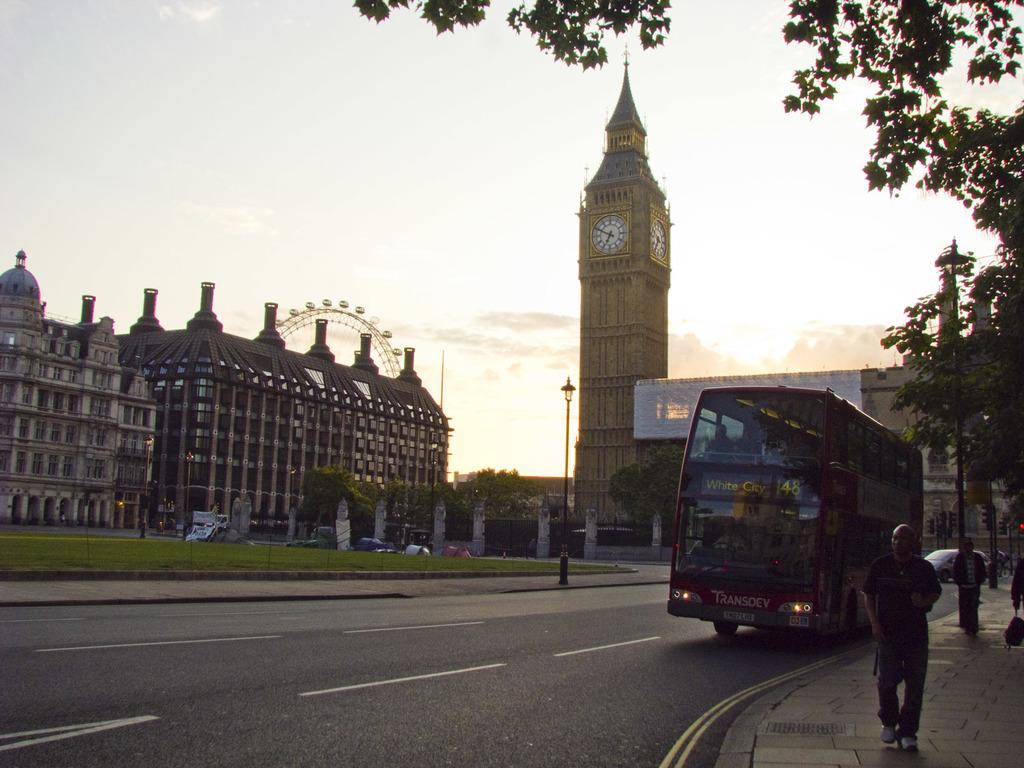What time is on the clock?
Offer a terse response. 6:50. What is the bus route number?
Ensure brevity in your answer.  48. 